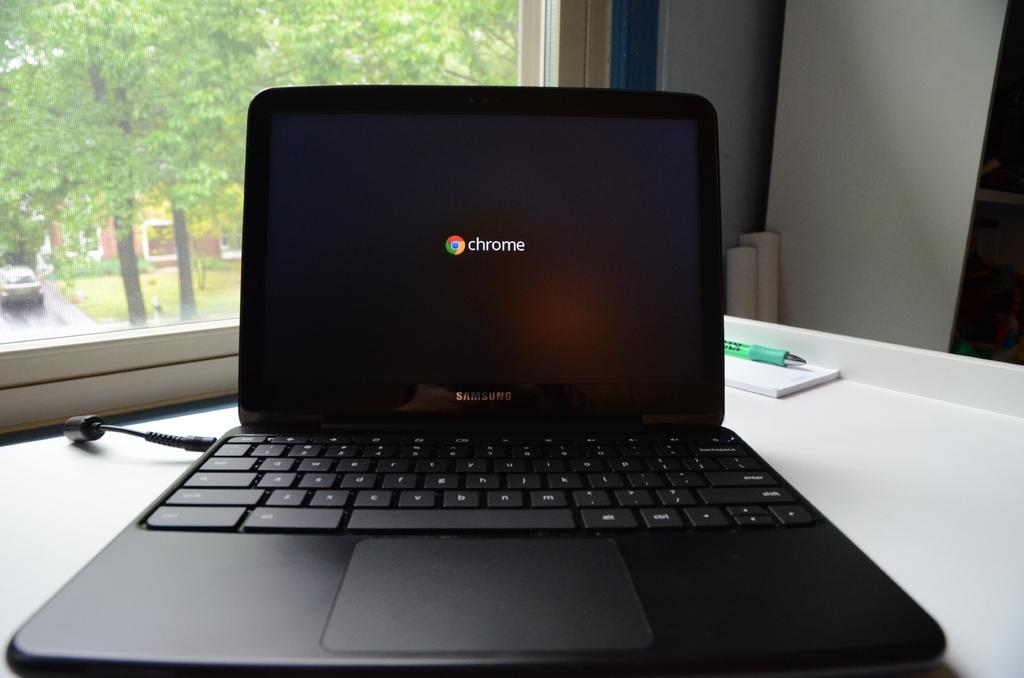What electronic device is present in the image? There is a laptop in the image. What writing instrument is visible in the image? There is a pen in the image. What can be seen through the window in the image? Trees and a vehicle on the road are visible through the window. How many windows are present in the image? The provided facts only mention one window in the image. What type of cabbage is being harvested in the image? There is no cabbage present in the image; it features a laptop, a pen, a window, trees, and a vehicle on the road. 